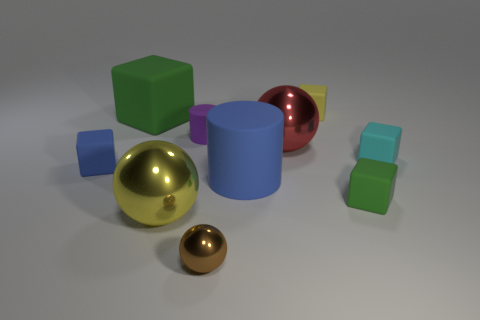Are there any other things that are the same color as the large cylinder?
Your answer should be compact. Yes. How many yellow rubber objects are the same size as the cyan thing?
Give a very brief answer. 1. Are there more big yellow metal balls that are to the right of the small blue block than spheres that are in front of the brown metal object?
Give a very brief answer. Yes. There is a tiny rubber object that is on the right side of the green object that is in front of the tiny purple matte cylinder; what color is it?
Offer a terse response. Cyan. Is the material of the yellow sphere the same as the small purple thing?
Your response must be concise. No. Is there a big yellow shiny thing of the same shape as the tiny brown metal object?
Offer a terse response. Yes. There is a matte object that is in front of the blue cylinder; does it have the same color as the large cube?
Keep it short and to the point. Yes. Does the green block that is in front of the big red metal sphere have the same size as the yellow thing behind the tiny cyan block?
Ensure brevity in your answer.  Yes. What size is the yellow sphere that is the same material as the big red object?
Your answer should be very brief. Large. What number of green cubes are both on the right side of the purple matte cylinder and left of the purple rubber object?
Your response must be concise. 0. 